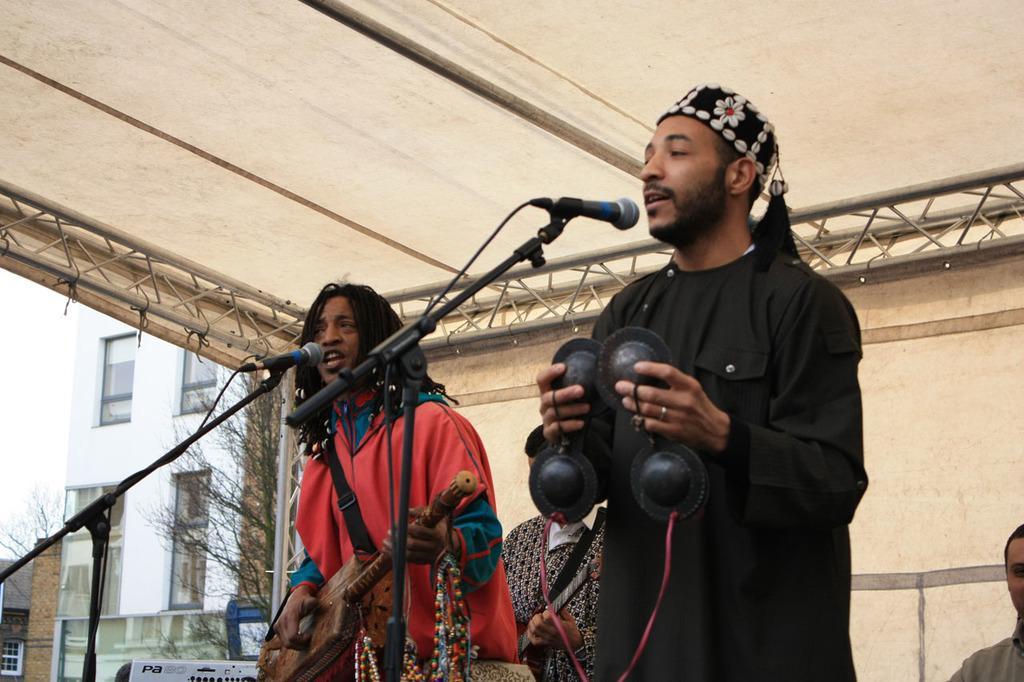Could you give a brief overview of what you see in this image? In this image we can see men standing by holding musical instruments in their hands and mics are placed in front of them. In the background we can see buildings, trees, bins, tent, iron grills and sky. 